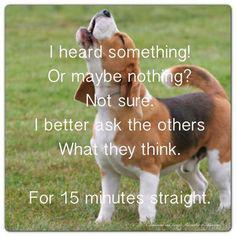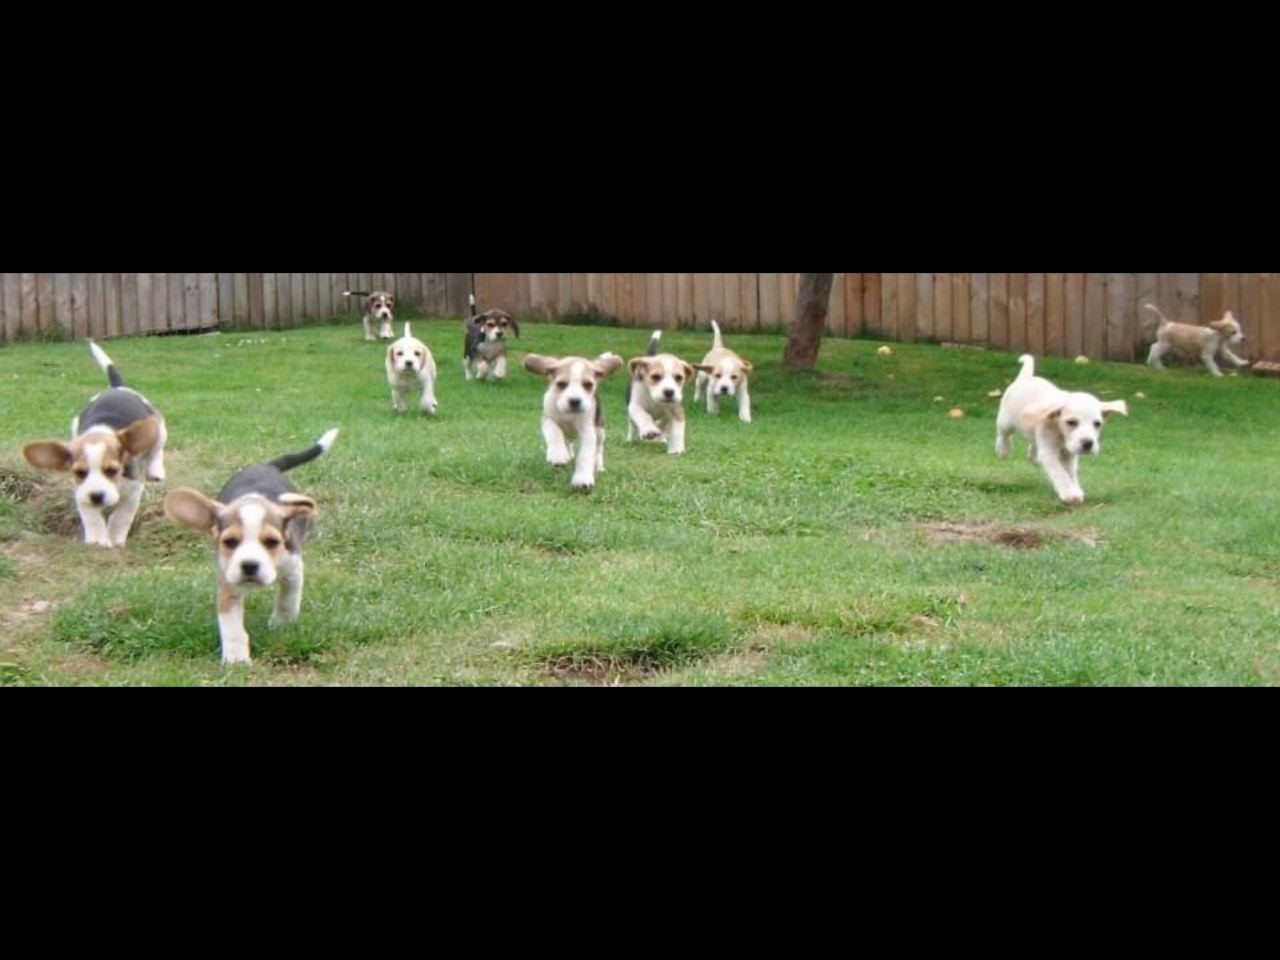The first image is the image on the left, the second image is the image on the right. For the images shown, is this caption "One image contains a single Beagle and a girl in a purple shirt on an agility course." true? Answer yes or no. No. 